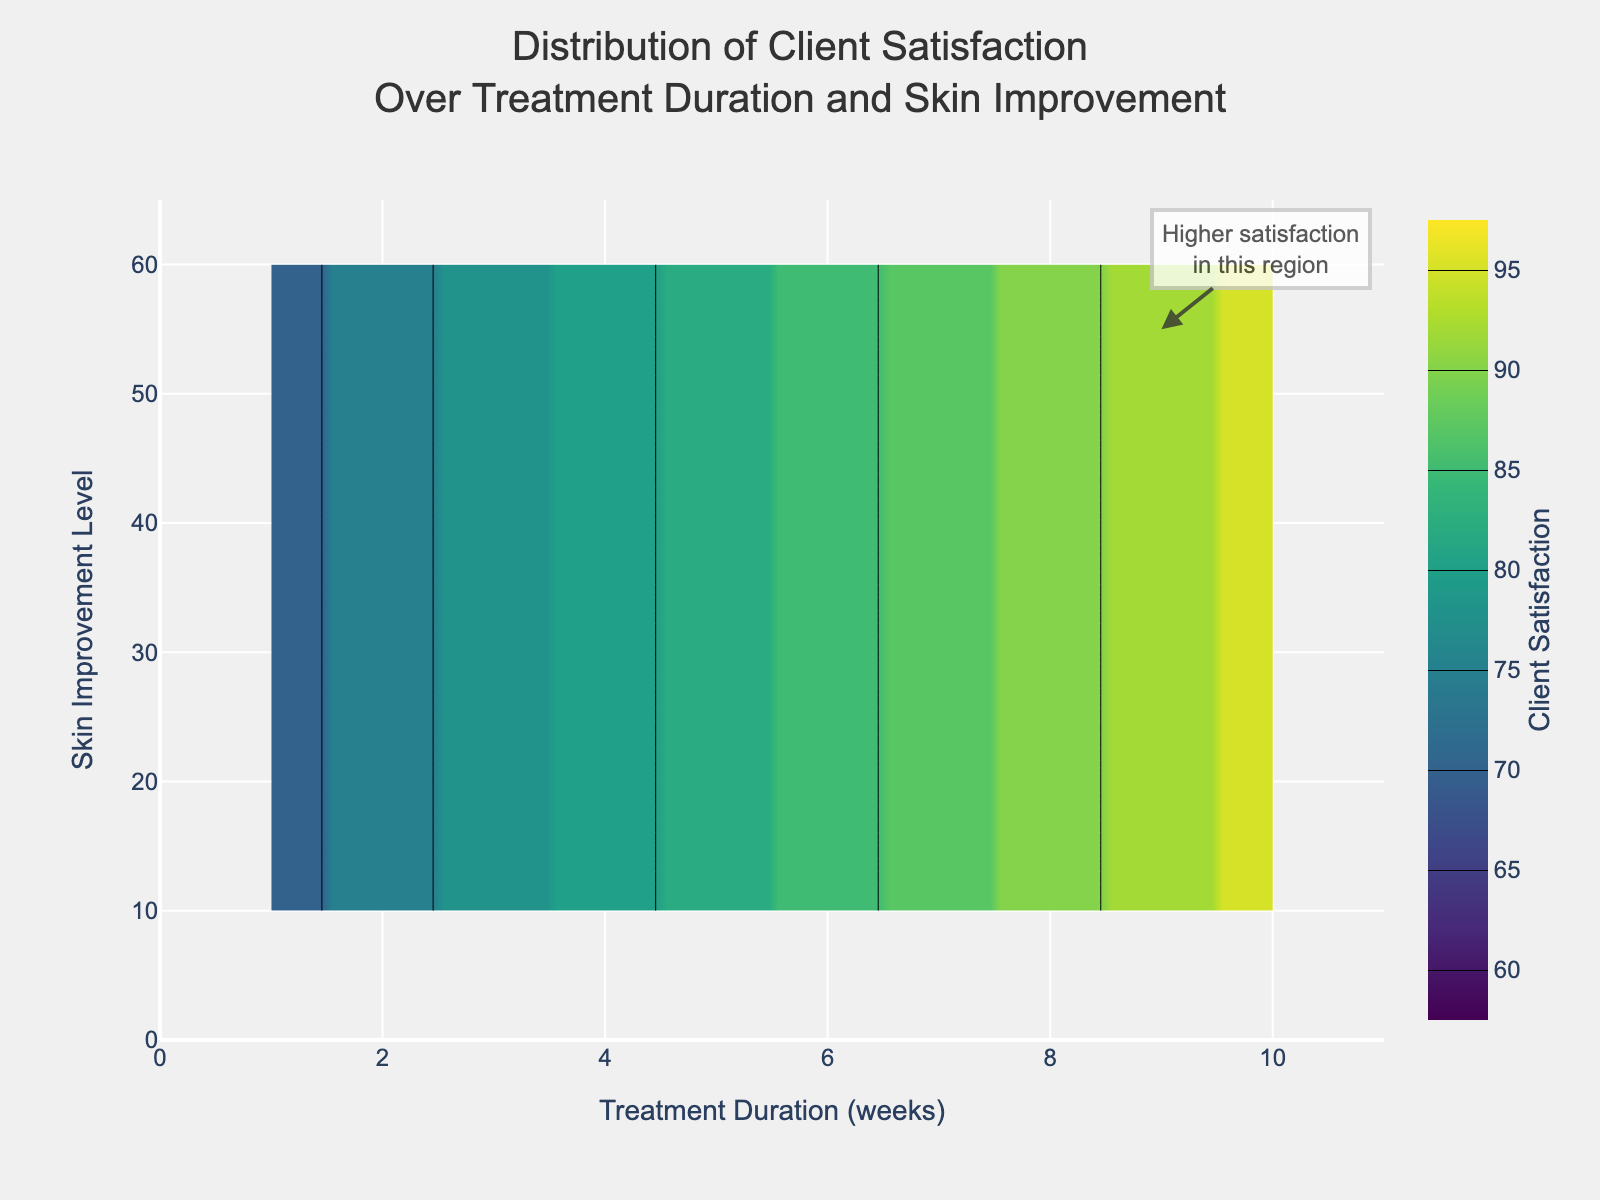What is the title of the plot? The title is typically displayed at the top center of the plot. By looking at this area, you can read the title.
Answer: Distribution of Client Satisfaction Over Treatment Duration and Skin Improvement What is the range of the x-axis? Look at the x-axis labeled "Treatment Duration (weeks)" and check the minimum and maximum values shown on the axis.
Answer: 0 to 11 How is client satisfaction represented in this plot? Client satisfaction is represented by the color intensity in the contour plot. Darker colors indicate higher satisfaction levels.
Answer: By color intensity What is the highest level of client satisfaction indicated in the plot? Check the color bar on the right-hand side which shows the range of client satisfaction values. The highest value represented on the color bar shows the peak satisfaction level.
Answer: 95 Which region shows higher satisfaction, shorter or longer treatment durations? Observe the color patterns across different treatment durations. Generally, areas with darker colors indicate higher satisfaction.
Answer: Longer treatment durations What's the relationship between skin improvement level and client satisfaction? By following the gradient of colors from low to high skin improvement levels, you can see that higher skin improvement levels correspond to higher client satisfaction.
Answer: Higher skin improvement levels correspond to higher client satisfaction Does the annotation point to a high or low satisfaction region? Read the text of the annotation and check the area it's pointing to on the plot. The annotation text and the surrounding color will clarify this.
Answer: High satisfaction region What skin improvement level corresponds to a client satisfaction of 85? Follow the colorbar and find the 85 mark. Trace horizontally from this value to the corresponding skin improvement level.
Answer: 40 to 45 Which treatment duration shows the greatest variation in client satisfaction? Look for the range on the x-axis where the color transition is the most varied. This indicates varying levels of client satisfaction.
Answer: Around 1 to 5 weeks If a new treatment was introduced and showed a skin improvement of 30, what treatment duration would you recommend for reaching client satisfaction above 75? Locate the skin improvement level of 30 on the y-axis and follow the colors horizontally to find the duration that corresponds to a satisfaction of over 75.
Answer: About 4 weeks 